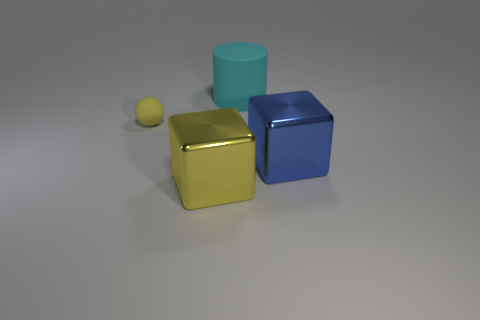Is the number of large yellow metallic things greater than the number of gray spheres? yes 